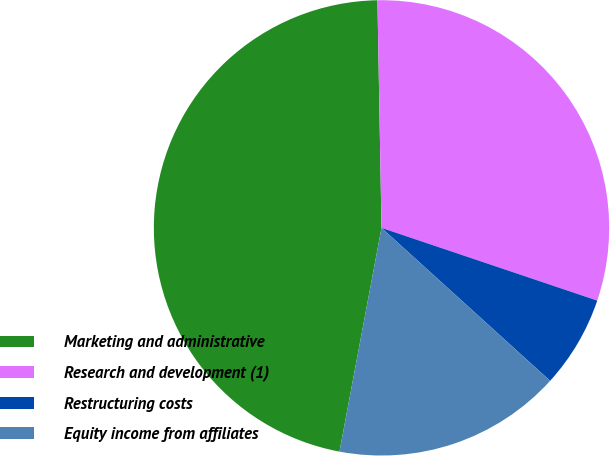<chart> <loc_0><loc_0><loc_500><loc_500><pie_chart><fcel>Marketing and administrative<fcel>Research and development (1)<fcel>Restructuring costs<fcel>Equity income from affiliates<nl><fcel>46.76%<fcel>30.46%<fcel>6.55%<fcel>16.23%<nl></chart> 